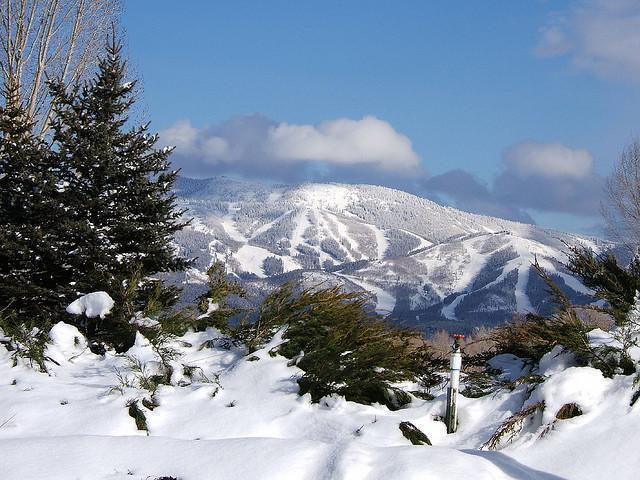How many signs are there?
Give a very brief answer. 0. How many cars are in front of the motorcycle?
Give a very brief answer. 0. 